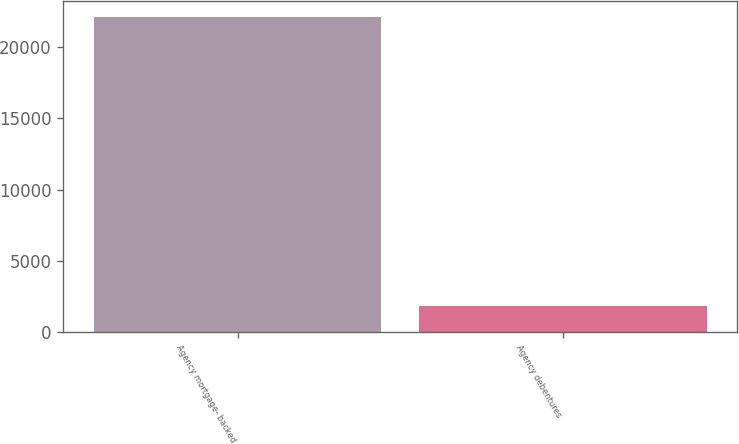Convert chart. <chart><loc_0><loc_0><loc_500><loc_500><bar_chart><fcel>Agency mortgage- backed<fcel>Agency debentures<nl><fcel>22140<fcel>1824<nl></chart> 